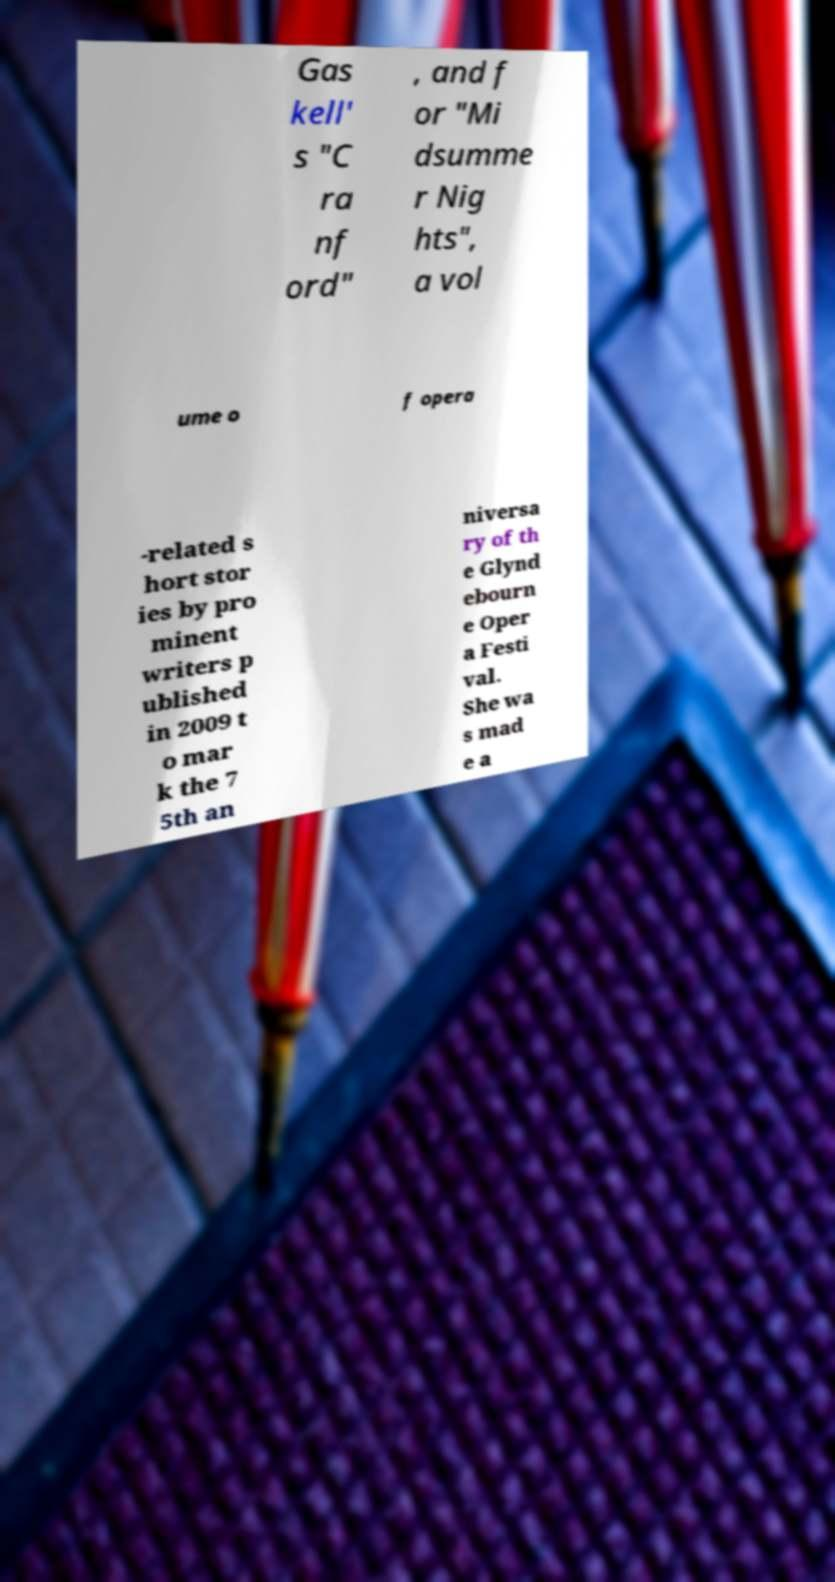I need the written content from this picture converted into text. Can you do that? Gas kell' s "C ra nf ord" , and f or "Mi dsumme r Nig hts", a vol ume o f opera -related s hort stor ies by pro minent writers p ublished in 2009 t o mar k the 7 5th an niversa ry of th e Glynd ebourn e Oper a Festi val. She wa s mad e a 